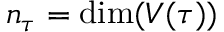<formula> <loc_0><loc_0><loc_500><loc_500>n _ { \tau } = \dim ( V ( \tau ) )</formula> 